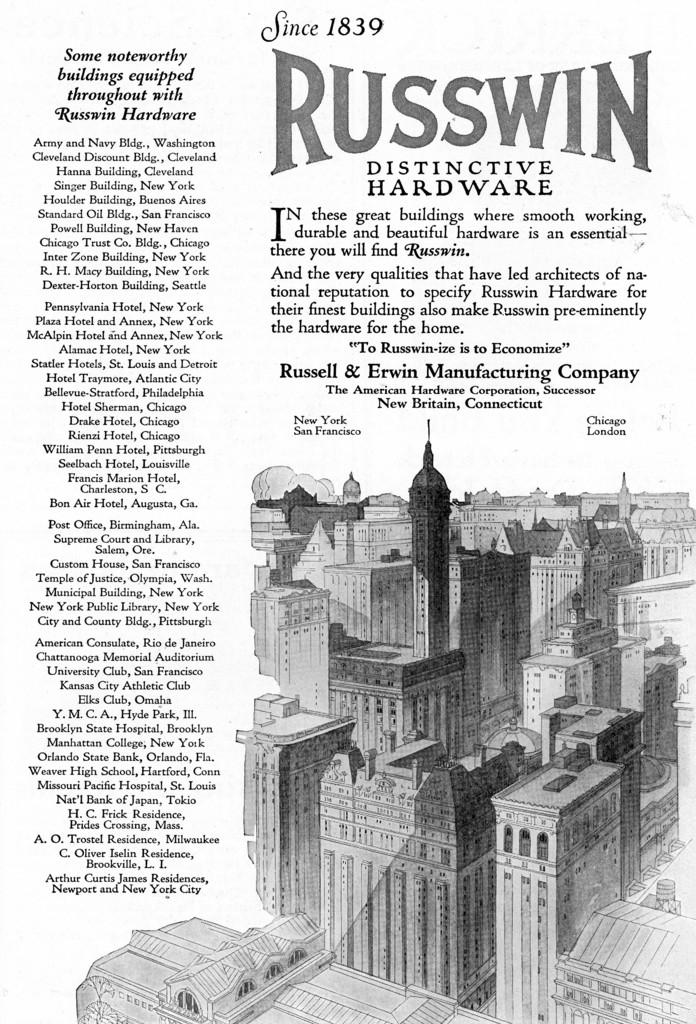What is the main object in the image? There is a magazine in the image. What type of content can be found in the magazine? The magazine contains information. Can you describe any specific images or illustrations within the magazine? There is an image of buildings in the magazine. What is the name associated with the magazine? The name "Russ win" is associated with the magazine. What type of twig is used as a bookmark in the magazine? There is no twig present in the image, and therefore no bookmark can be observed. 